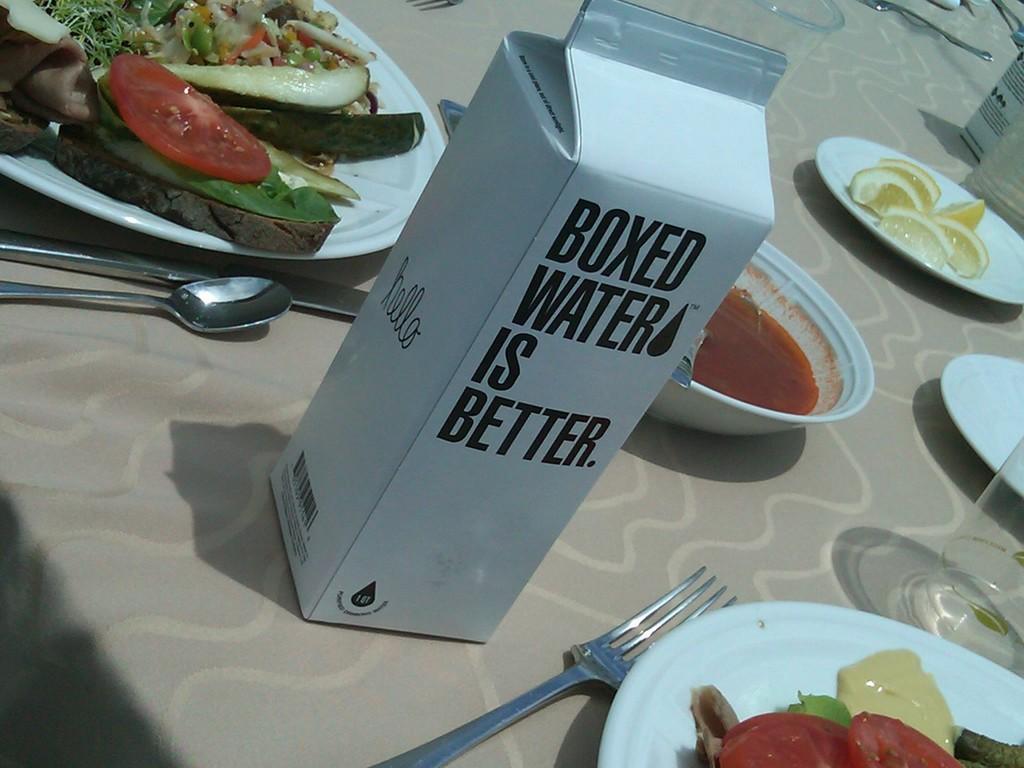Could you give a brief overview of what you see in this image? In this image there is a tablecloth, forks, spoons, plates, bowl, packet, glasses, food and objects. 